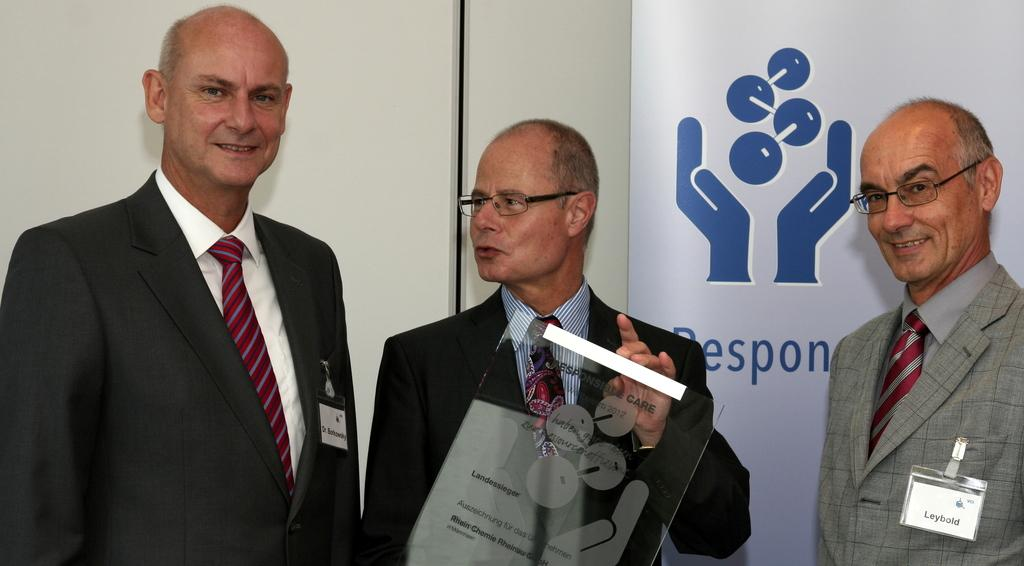How many people are in the image? There are three men in the image. What is the middle person holding? The middle person is holding a glass board. What can be seen in the background of the image? There is a wall and a hoarding in the background of the image. What type of camp can be seen in the image? There is no camp present in the image. What is the middle person using to support his neck in the image? The middle person is not using anything to support his neck in the image; he is holding a glass board. 